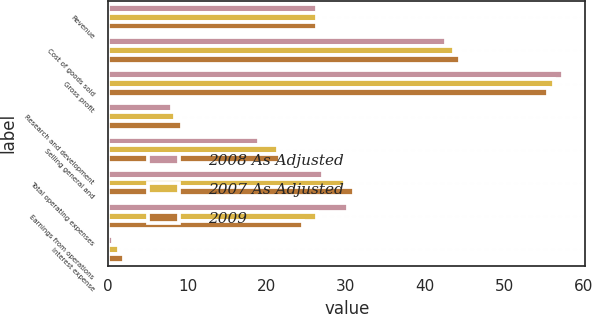<chart> <loc_0><loc_0><loc_500><loc_500><stacked_bar_chart><ecel><fcel>Revenue<fcel>Cost of goods sold<fcel>Gross profit<fcel>Research and development<fcel>Selling general and<fcel>Total operating expenses<fcel>Earnings from operations<fcel>Interest expense<nl><fcel>2008 As Adjusted<fcel>26.4<fcel>42.6<fcel>57.4<fcel>8<fcel>19.1<fcel>27.1<fcel>30.3<fcel>0.6<nl><fcel>2007 As Adjusted<fcel>26.4<fcel>43.7<fcel>56.3<fcel>8.4<fcel>21.5<fcel>29.9<fcel>26.4<fcel>1.3<nl><fcel>2009<fcel>26.4<fcel>44.4<fcel>55.6<fcel>9.3<fcel>21.7<fcel>31<fcel>24.6<fcel>2<nl></chart> 